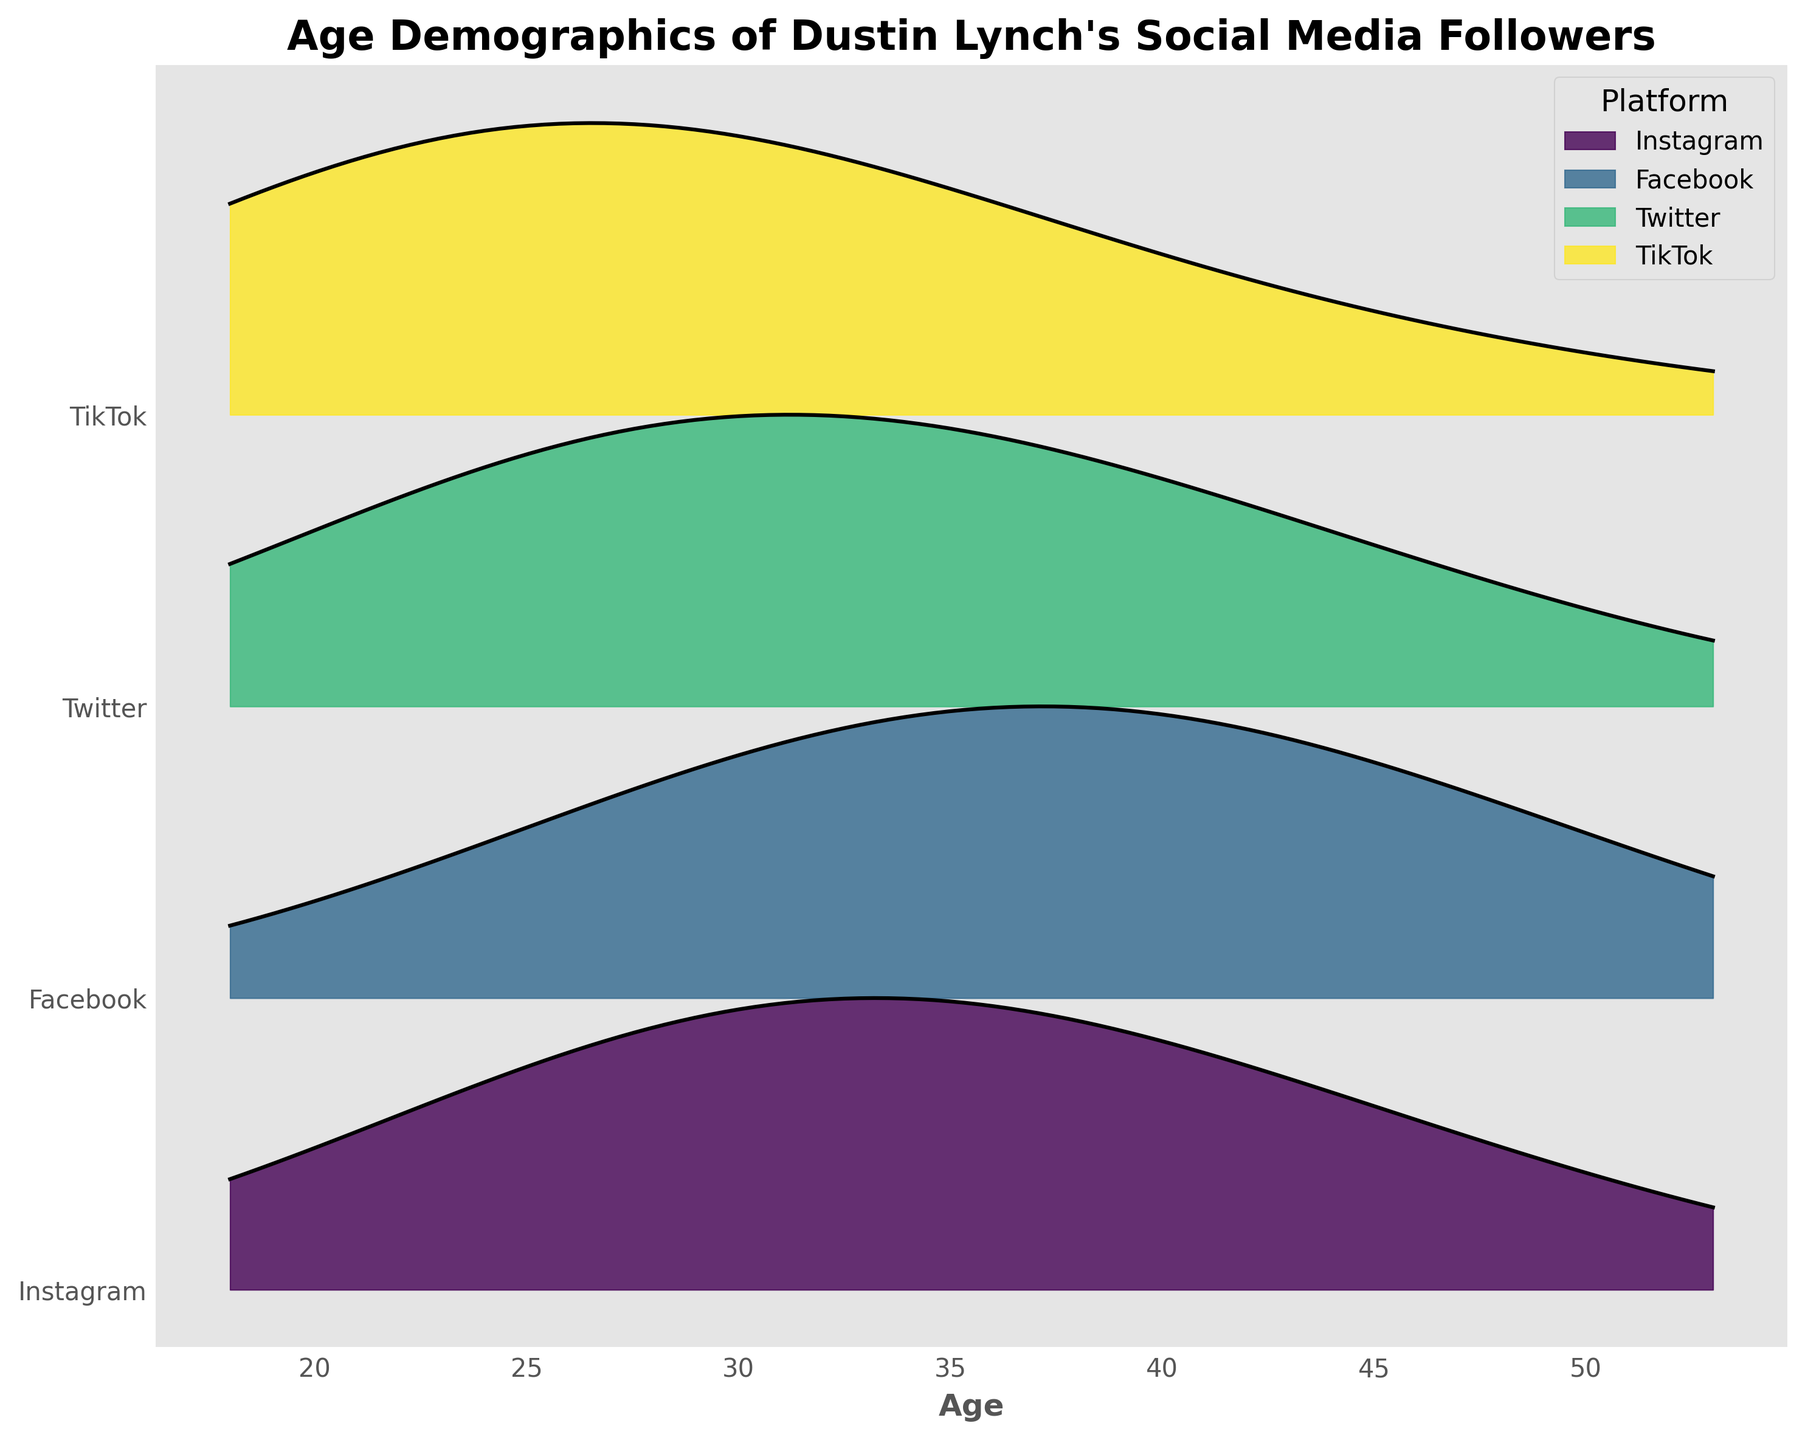Which social media platform has the highest density at age 32? From the plot, look at the density peaks for each platform at age 32. Instagram shows the highest density compared to others.
Answer: Instagram What is the overall trend in follower age distribution on TikTok? By examining the Ridgeline plot for TikTok, the densities at younger ages such as 18 and 25 are the highest, indicating that TikTok has a younger follower demographic.
Answer: Younger demographic Which platform has the greatest density peak around age 18? Check the height of the peaks for each platform around age 18. TikTok has the highest peak around age 18.
Answer: TikTok Comparing Facebook and Twitter, which platform has a higher density peak at age 39? Observe the peaks at age 39 for both Facebook and Twitter. Facebook has a higher peak at this age.
Answer: Facebook What age group has the lowest density on Instagram? By inspecting the densities plotted for Instagram, the age group 18 has the lowest density.
Answer: 18 Which platform has a more balanced distribution of ages among followers? Examine the spread and density heights across different ages for each platform. Facebook shows a relatively balanced distribution among different age groups.
Answer: Facebook How does the age distribution of Instagram followers compare to that of Twitter followers? Compare the ridgelines of Instagram and Twitter. Instagram has higher densities at age 32 and 39, while Twitter peaks earlier at age 25 and shows a decline after age 32.
Answer: Instagram peaks later At what age does the density peak for Facebook followers? Identify the highest point of the density line for Facebook. This occurs at age 39.
Answer: 39 What platform has the smallest density peak, and at what age? Look at the smallest peaks among all the platforms. Twitter has the smallest peak at age 53.
Answer: Twitter, 53 What is the title of the plot, and what does it indicate? The title of the plot is "Age Demographics of Dustin Lynch's Social Media Followers". This indicates that the plot is showing the age distribution of followers across different social media platforms.
Answer: Age Demographics of Dustin Lynch's Social Media Followers 